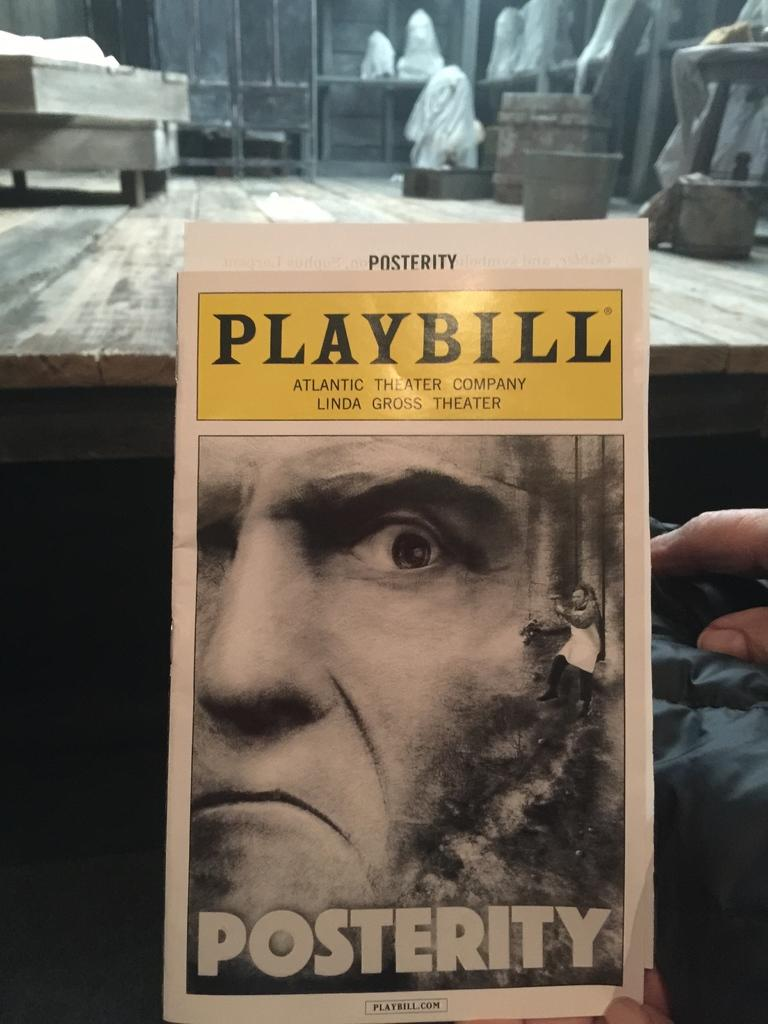<image>
Create a compact narrative representing the image presented. The playbill for the atlantic theater company is displayed. 